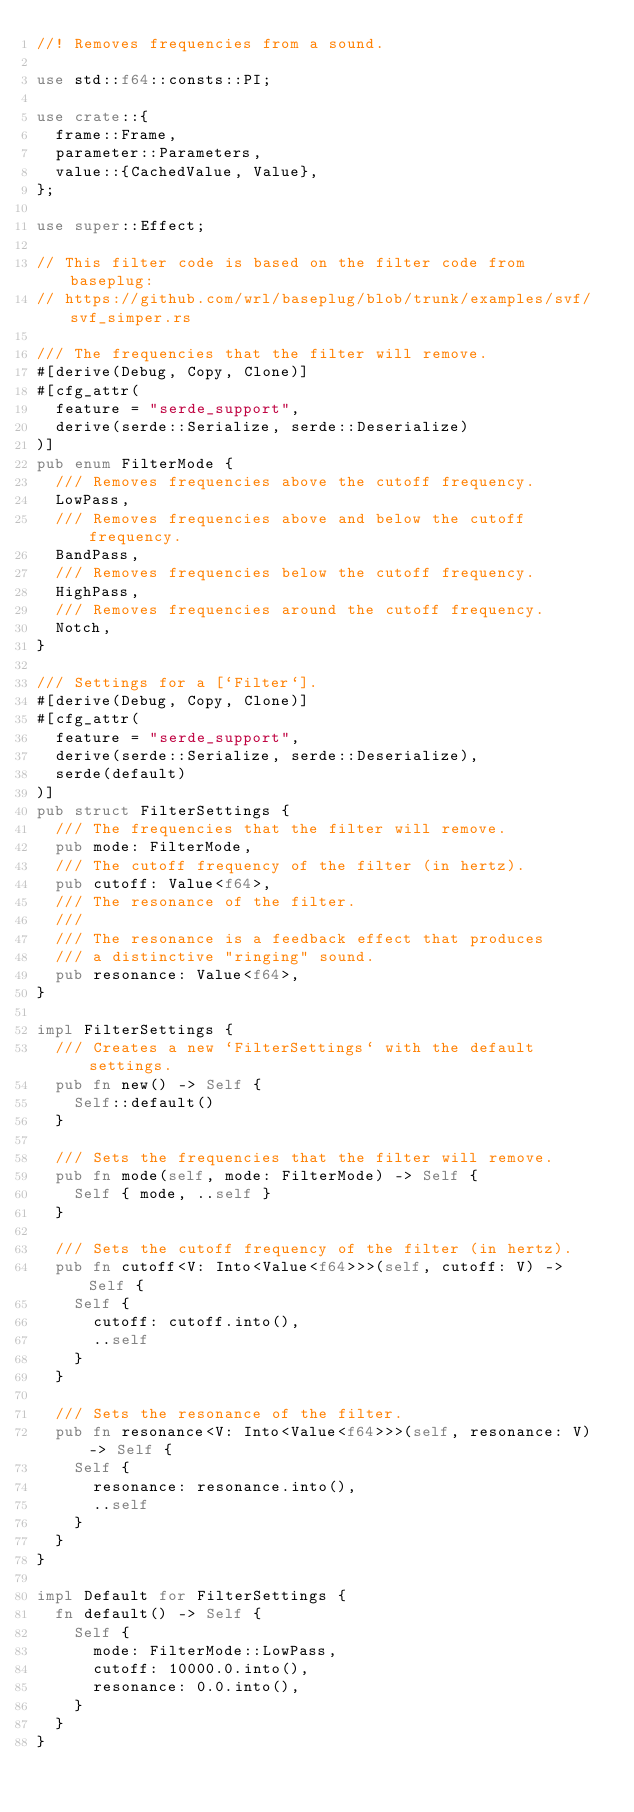<code> <loc_0><loc_0><loc_500><loc_500><_Rust_>//! Removes frequencies from a sound.

use std::f64::consts::PI;

use crate::{
	frame::Frame,
	parameter::Parameters,
	value::{CachedValue, Value},
};

use super::Effect;

// This filter code is based on the filter code from baseplug:
// https://github.com/wrl/baseplug/blob/trunk/examples/svf/svf_simper.rs

/// The frequencies that the filter will remove.
#[derive(Debug, Copy, Clone)]
#[cfg_attr(
	feature = "serde_support",
	derive(serde::Serialize, serde::Deserialize)
)]
pub enum FilterMode {
	/// Removes frequencies above the cutoff frequency.
	LowPass,
	/// Removes frequencies above and below the cutoff frequency.
	BandPass,
	/// Removes frequencies below the cutoff frequency.
	HighPass,
	/// Removes frequencies around the cutoff frequency.
	Notch,
}

/// Settings for a [`Filter`].
#[derive(Debug, Copy, Clone)]
#[cfg_attr(
	feature = "serde_support",
	derive(serde::Serialize, serde::Deserialize),
	serde(default)
)]
pub struct FilterSettings {
	/// The frequencies that the filter will remove.
	pub mode: FilterMode,
	/// The cutoff frequency of the filter (in hertz).
	pub cutoff: Value<f64>,
	/// The resonance of the filter.
	///
	/// The resonance is a feedback effect that produces
	/// a distinctive "ringing" sound.
	pub resonance: Value<f64>,
}

impl FilterSettings {
	/// Creates a new `FilterSettings` with the default settings.
	pub fn new() -> Self {
		Self::default()
	}

	/// Sets the frequencies that the filter will remove.
	pub fn mode(self, mode: FilterMode) -> Self {
		Self { mode, ..self }
	}

	/// Sets the cutoff frequency of the filter (in hertz).
	pub fn cutoff<V: Into<Value<f64>>>(self, cutoff: V) -> Self {
		Self {
			cutoff: cutoff.into(),
			..self
		}
	}

	/// Sets the resonance of the filter.
	pub fn resonance<V: Into<Value<f64>>>(self, resonance: V) -> Self {
		Self {
			resonance: resonance.into(),
			..self
		}
	}
}

impl Default for FilterSettings {
	fn default() -> Self {
		Self {
			mode: FilterMode::LowPass,
			cutoff: 10000.0.into(),
			resonance: 0.0.into(),
		}
	}
}
</code> 